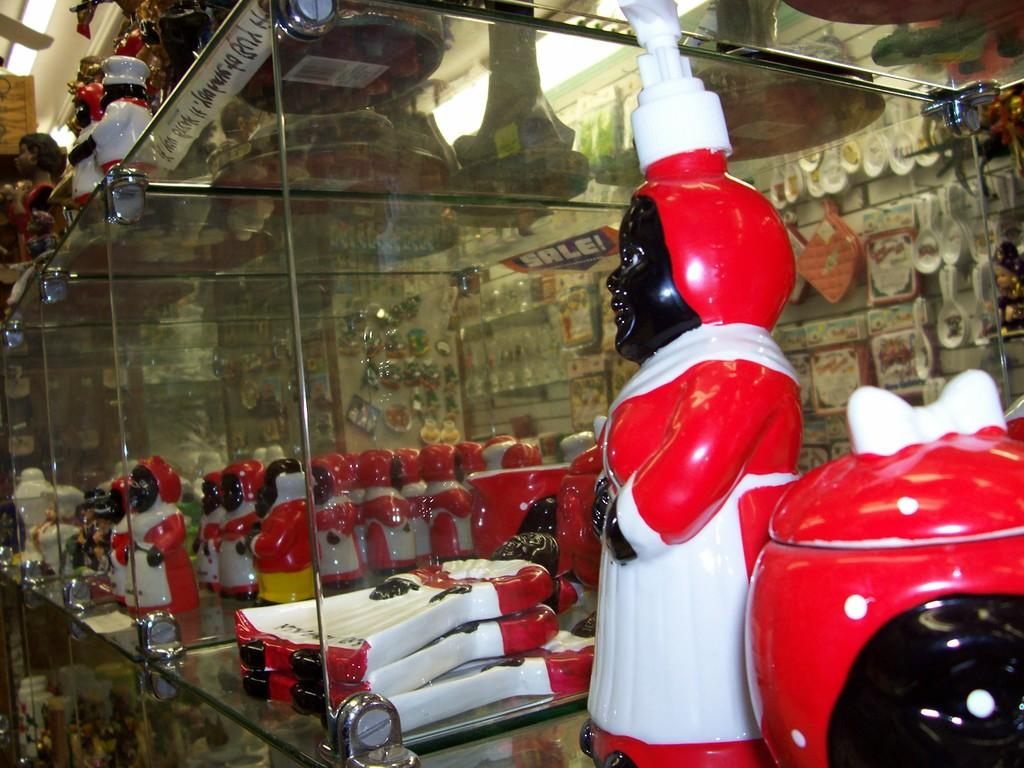What type of objects can be seen on the right side of the image? There are toys on the right side of the image. How are the toys arranged in the image? The toys are arranged in shelves in the center of the image. What can be seen in the background of the image? There is a wall and objects visible in the background of the image. Can you see a nest of jellyfish in the image? There is no nest of jellyfish present in the image. 